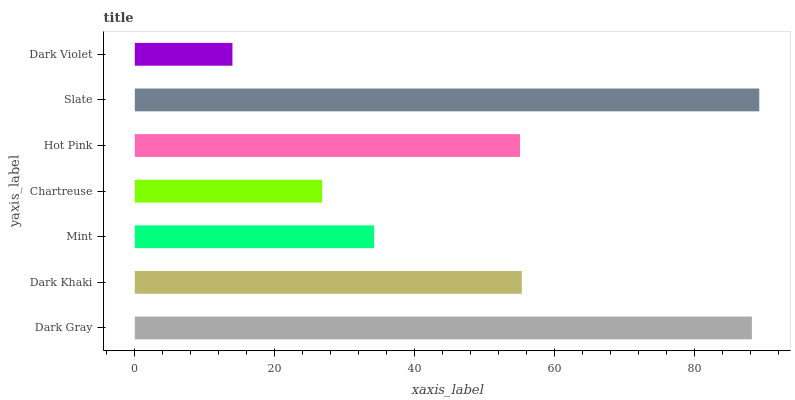Is Dark Violet the minimum?
Answer yes or no. Yes. Is Slate the maximum?
Answer yes or no. Yes. Is Dark Khaki the minimum?
Answer yes or no. No. Is Dark Khaki the maximum?
Answer yes or no. No. Is Dark Gray greater than Dark Khaki?
Answer yes or no. Yes. Is Dark Khaki less than Dark Gray?
Answer yes or no. Yes. Is Dark Khaki greater than Dark Gray?
Answer yes or no. No. Is Dark Gray less than Dark Khaki?
Answer yes or no. No. Is Hot Pink the high median?
Answer yes or no. Yes. Is Hot Pink the low median?
Answer yes or no. Yes. Is Dark Violet the high median?
Answer yes or no. No. Is Dark Khaki the low median?
Answer yes or no. No. 